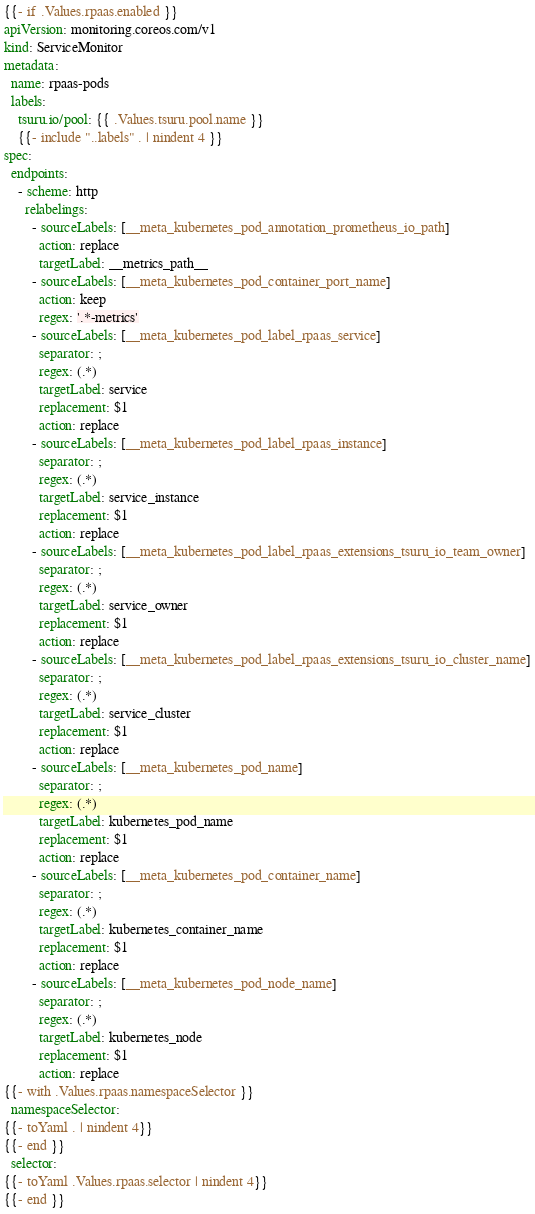Convert code to text. <code><loc_0><loc_0><loc_500><loc_500><_YAML_>{{- if .Values.rpaas.enabled }}
apiVersion: monitoring.coreos.com/v1
kind: ServiceMonitor
metadata:
  name: rpaas-pods
  labels:
    tsuru.io/pool: {{ .Values.tsuru.pool.name }}
    {{- include "..labels" . | nindent 4 }}
spec:
  endpoints:
    - scheme: http
      relabelings:
        - sourceLabels: [__meta_kubernetes_pod_annotation_prometheus_io_path]
          action: replace
          targetLabel: __metrics_path__
        - sourceLabels: [__meta_kubernetes_pod_container_port_name]
          action: keep
          regex: '.*-metrics'
        - sourceLabels: [__meta_kubernetes_pod_label_rpaas_service]
          separator: ;
          regex: (.*)
          targetLabel: service
          replacement: $1
          action: replace
        - sourceLabels: [__meta_kubernetes_pod_label_rpaas_instance]
          separator: ;
          regex: (.*)
          targetLabel: service_instance
          replacement: $1
          action: replace
        - sourceLabels: [__meta_kubernetes_pod_label_rpaas_extensions_tsuru_io_team_owner]
          separator: ;
          regex: (.*)
          targetLabel: service_owner
          replacement: $1
          action: replace
        - sourceLabels: [__meta_kubernetes_pod_label_rpaas_extensions_tsuru_io_cluster_name]
          separator: ;
          regex: (.*)
          targetLabel: service_cluster
          replacement: $1
          action: replace
        - sourceLabels: [__meta_kubernetes_pod_name]
          separator: ;
          regex: (.*)
          targetLabel: kubernetes_pod_name
          replacement: $1
          action: replace
        - sourceLabels: [__meta_kubernetes_pod_container_name]
          separator: ;
          regex: (.*)
          targetLabel: kubernetes_container_name
          replacement: $1
          action: replace
        - sourceLabels: [__meta_kubernetes_pod_node_name]
          separator: ;
          regex: (.*)
          targetLabel: kubernetes_node
          replacement: $1
          action: replace
{{- with .Values.rpaas.namespaceSelector }}
  namespaceSelector:
{{- toYaml . | nindent 4}}
{{- end }}
  selector:
{{- toYaml .Values.rpaas.selector | nindent 4}}
{{- end }}</code> 